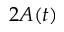Convert formula to latex. <formula><loc_0><loc_0><loc_500><loc_500>2 A ( t )</formula> 